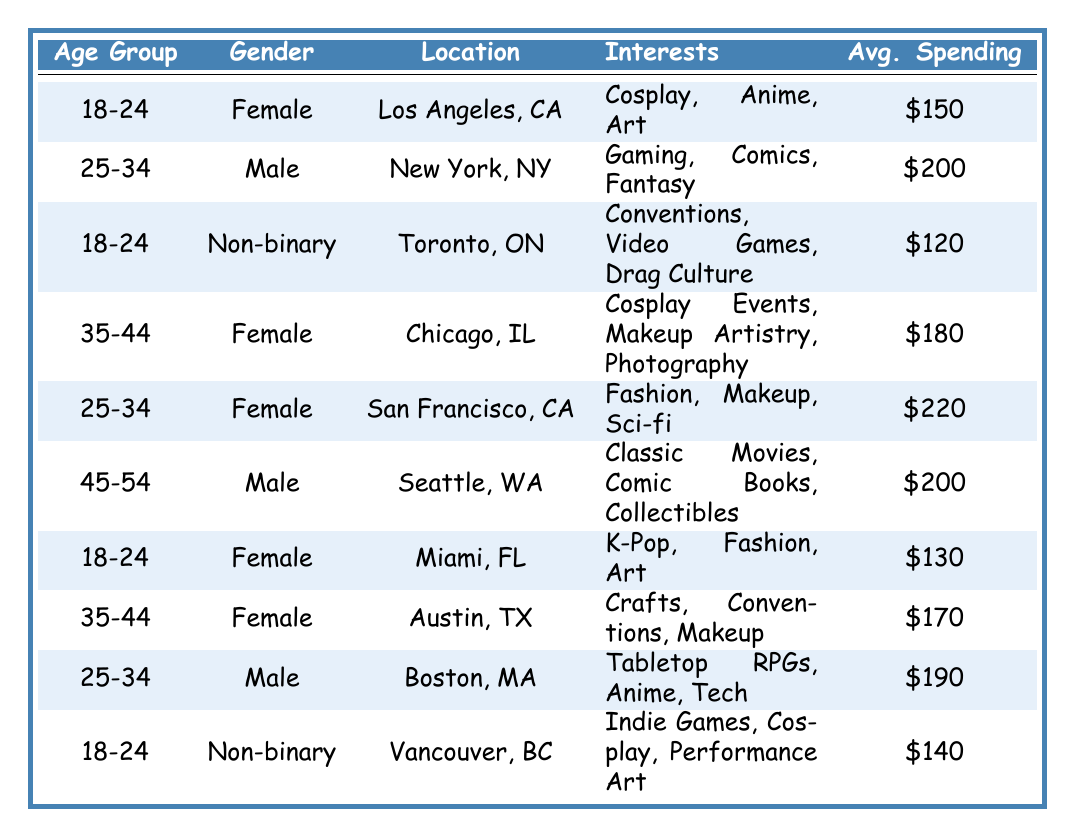What is the average spending of clients in the age group 18-24? The average spending for 18-24 clients can be calculated by looking at the values: $150 (Female, Los Angeles) + $120 (Non-binary, Toronto) + $130 (Female, Miami) + $140 (Non-binary, Vancouver). There are 4 entries; thus, the average is (150 + 120 + 130 + 140) / 4 = $135.
Answer: $135 How many clients are located in California? From the table, the clients in California are: one from Los Angeles, one from San Francisco, and one from Austin (though Austin is in Texas, Los Angeles and San Francisco are in California). So, there are 2 clients located in California.
Answer: 2 Is there any client in the age group 45-54? Yes, there is one client aged 45-54, which is a male from Seattle, WA.
Answer: Yes Which gender has the highest average spending among the clients? The average spending is calculated as follows: For Female:($150 + $180 + $220 + $130 + $170) / 5 = $170; For Male: ($200 + $200 + $190) / 3 = $196.67; For Non-binary: ($120 + $140) / 2 = $130. The highest average is for Male with $196.67.
Answer: Male What are the interests of the client from Boston? The client from Boston, MA is 25-34 years old, male, and has interests in Tabletop RPGs, Anime, and Tech.
Answer: Tabletop RPGs, Anime, Tech Which location has the most frequent clients? The locations with clients are Los Angeles, New York, Toronto, Chicago, San Francisco, Seattle, Miami, Austin, Boston, and Vancouver. There are no repeated locations. Each location appears once. Thus, none is more frequent than others.
Answer: None What is the total average spending for clients aged 35-44? The average spending for clients aged 35-44 are $180 (Female, Chicago) and $170 (Female, Austin). The total average is ($180 + $170) / 2 = $175.
Answer: $175 In which location is the highest average spending for clients? The highest average spending noted is $220 in San Francisco, CA, from a 25-34 female client.
Answer: San Francisco, CA Are there more female clients than male clients? There are 5 female clients and 3 male clients; hence there are more female clients compared to male clients.
Answer: Yes What is the average age of clients in Toronto and Vancouver combined? The average age of clients in Toronto (18-24, Non-binary) and Vancouver (18-24, Non-binary) is determined by taking the same age group of 18-24. To average, it's still 18-24 since both are in the same age.
Answer: 18-24 What is the difference between the average spending of Female clients and Non-binary clients? The average spending for Female clients ($170) and Non-binary clients ($130) results in a difference of $170 - $130 = $40.
Answer: $40 